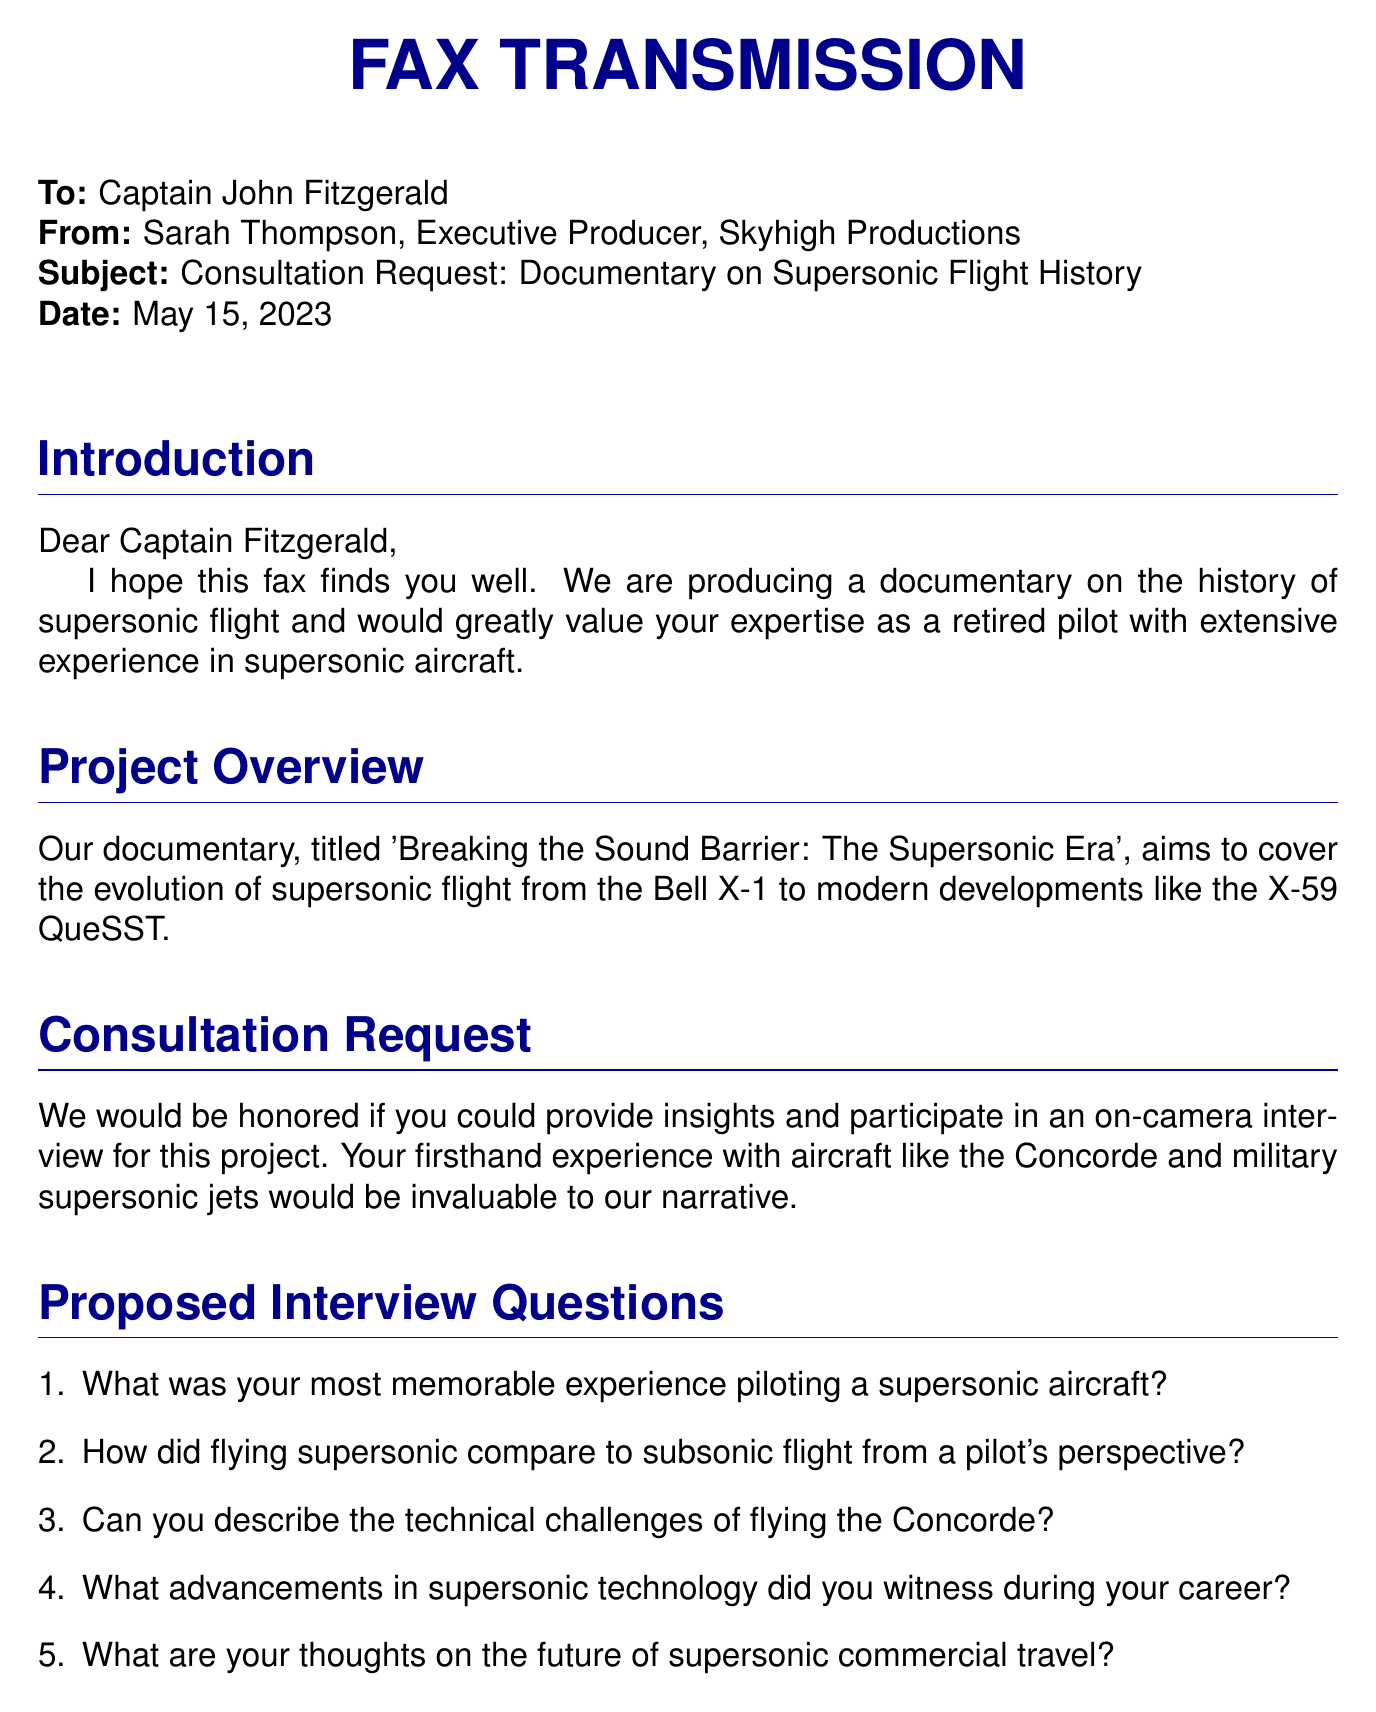What is the subject of the fax? The subject line of the fax states the main topic of the communication.
Answer: Consultation Request: Documentary on Supersonic Flight History Who is the sender of the fax? The sender is identified at the top of the document with a full name and title.
Answer: Sarah Thompson, Executive Producer What is the date of the fax? The date is explicitly indicated in the header section of the document.
Answer: May 15, 2023 What is the title of the documentary? The title is mentioned in the project overview section, specifying the theme of the documentary.
Answer: Breaking the Sound Barrier: The Supersonic Era How many proposed interview questions are listed? The number of proposed interview questions is determined by counting the items in the enumerated list.
Answer: Five What was one of the aircraft mentioned that Captain Fitzgerald has experience with? The document refers to a specific aircraft based on the context of the consultation request.
Answer: Concorde What company is producing the documentary? The document provides the name of the production company at the end.
Answer: Skyhigh Productions What address is listed for Skyhigh Productions? The document contains the complete address of the production company in the footer section.
Answer: 123 Aviation Way, Los Angeles, CA 90045 What type of consultation is being requested? The purpose of the fax is clearly defined in the consultation request section.
Answer: On-camera interview 